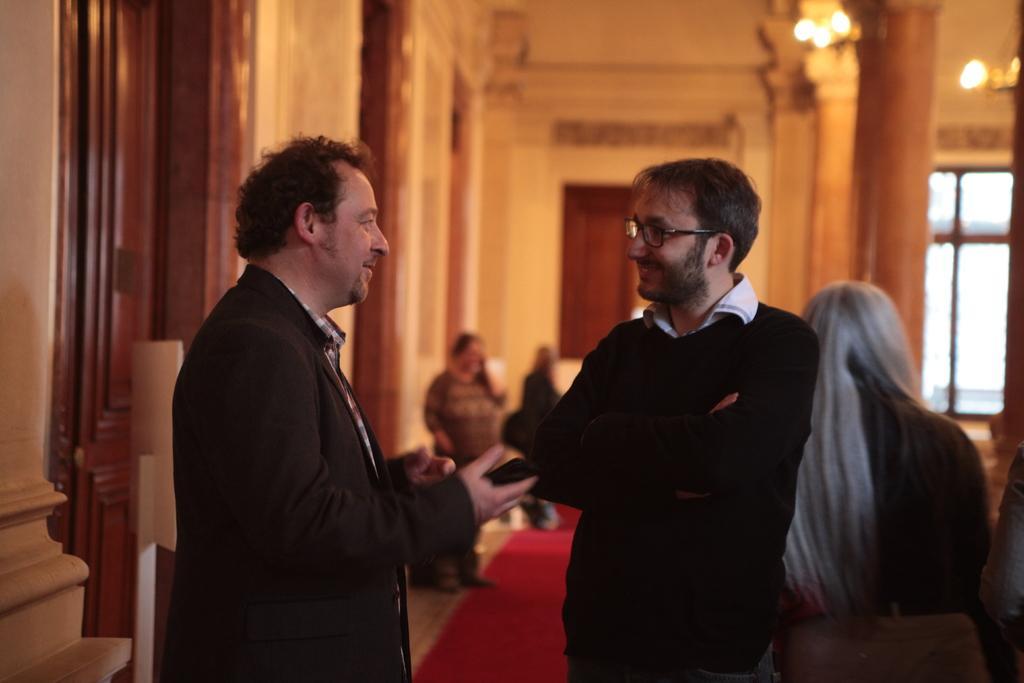Describe this image in one or two sentences. In this image I can see a group of people on the floor. In the background I can see a wall, pillars, door, lights and a window. This image is taken in a hall. 